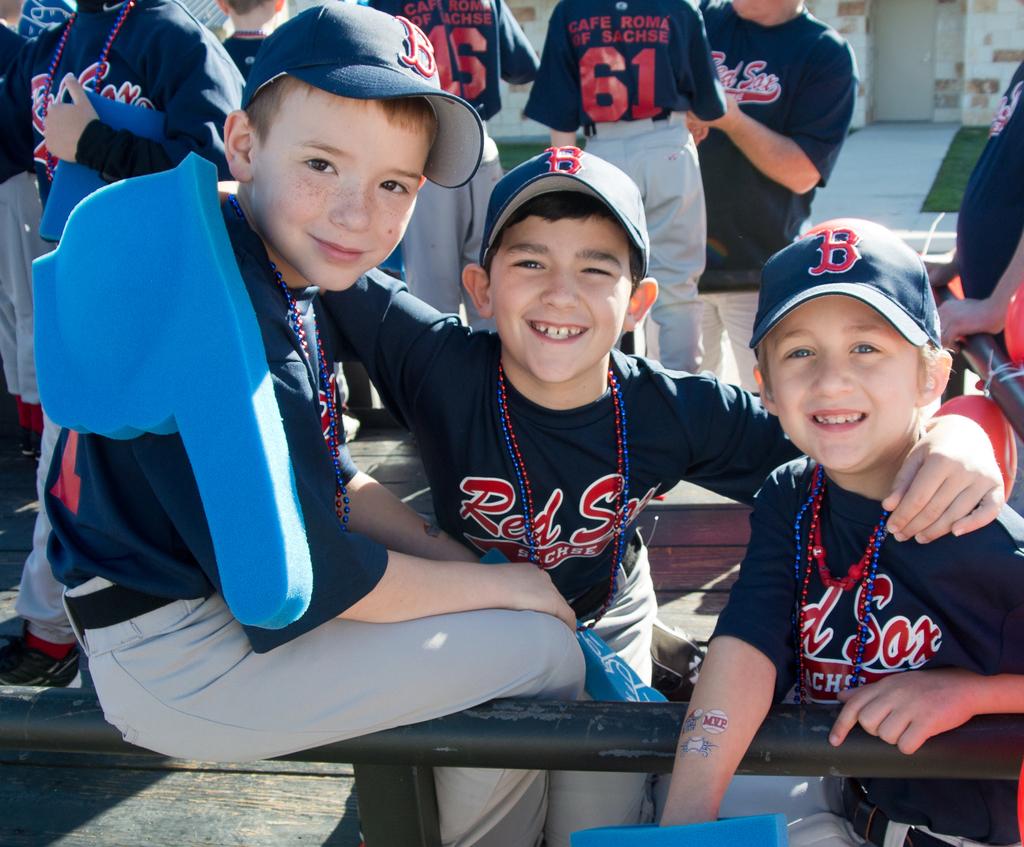Are you all red sox fans?
Provide a short and direct response. Answering does not require reading text in the image. What letter is on their hats?
Offer a terse response. B. 